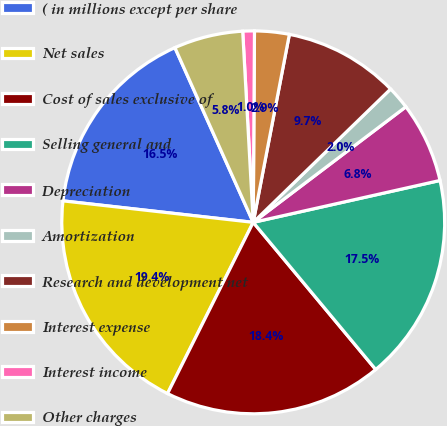Convert chart. <chart><loc_0><loc_0><loc_500><loc_500><pie_chart><fcel>( in millions except per share<fcel>Net sales<fcel>Cost of sales exclusive of<fcel>Selling general and<fcel>Depreciation<fcel>Amortization<fcel>Research and development net<fcel>Interest expense<fcel>Interest income<fcel>Other charges<nl><fcel>16.5%<fcel>19.4%<fcel>18.43%<fcel>17.46%<fcel>6.8%<fcel>1.95%<fcel>9.71%<fcel>2.92%<fcel>0.98%<fcel>5.83%<nl></chart> 